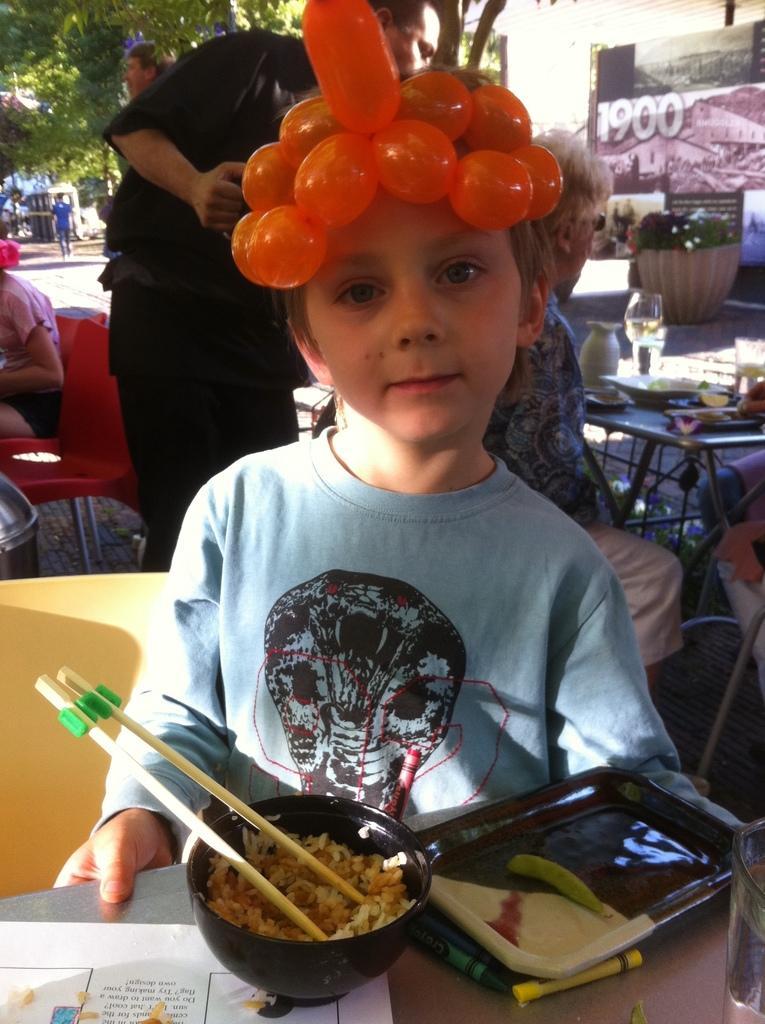Could you give a brief overview of what you see in this image? In this image I can see a boy wearing blue color t-shirt. In front of this boy there is a table on which a bowl with food and a tray are placed. In the background I can see few people are sitting on the chairs around the table. On the top of the image I can see the trees and a building. 